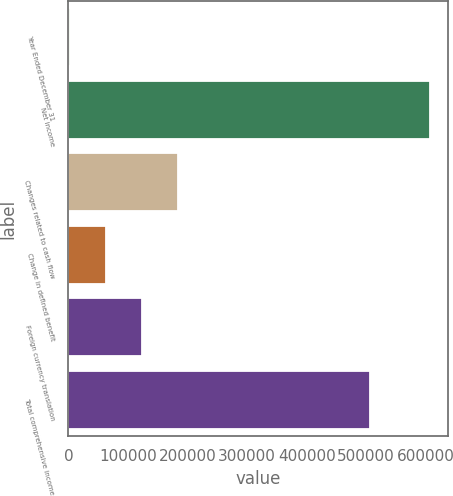<chart> <loc_0><loc_0><loc_500><loc_500><bar_chart><fcel>Year Ended December 31<fcel>Net income<fcel>Changes related to cash flow<fcel>Change in defined benefit<fcel>Foreign currency translation<fcel>Total comprehensive income<nl><fcel>2011<fcel>607421<fcel>183634<fcel>62552<fcel>123093<fcel>506417<nl></chart> 